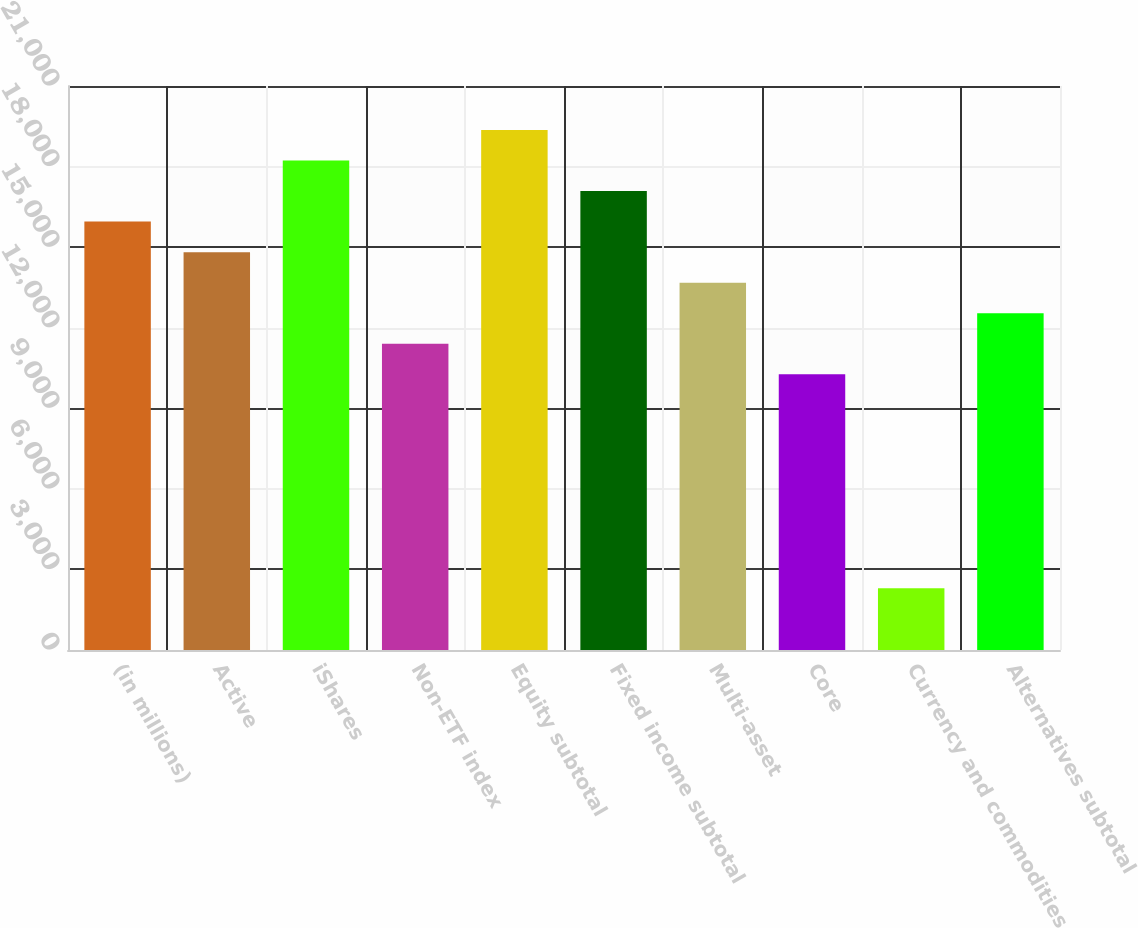Convert chart. <chart><loc_0><loc_0><loc_500><loc_500><bar_chart><fcel>(in millions)<fcel>Active<fcel>iShares<fcel>Non-ETF index<fcel>Equity subtotal<fcel>Fixed income subtotal<fcel>Multi-asset<fcel>Core<fcel>Currency and commodities<fcel>Alternatives subtotal<nl><fcel>15951<fcel>14813.5<fcel>18226<fcel>11401<fcel>19363.5<fcel>17088.5<fcel>13676<fcel>10263.5<fcel>2301<fcel>12538.5<nl></chart> 